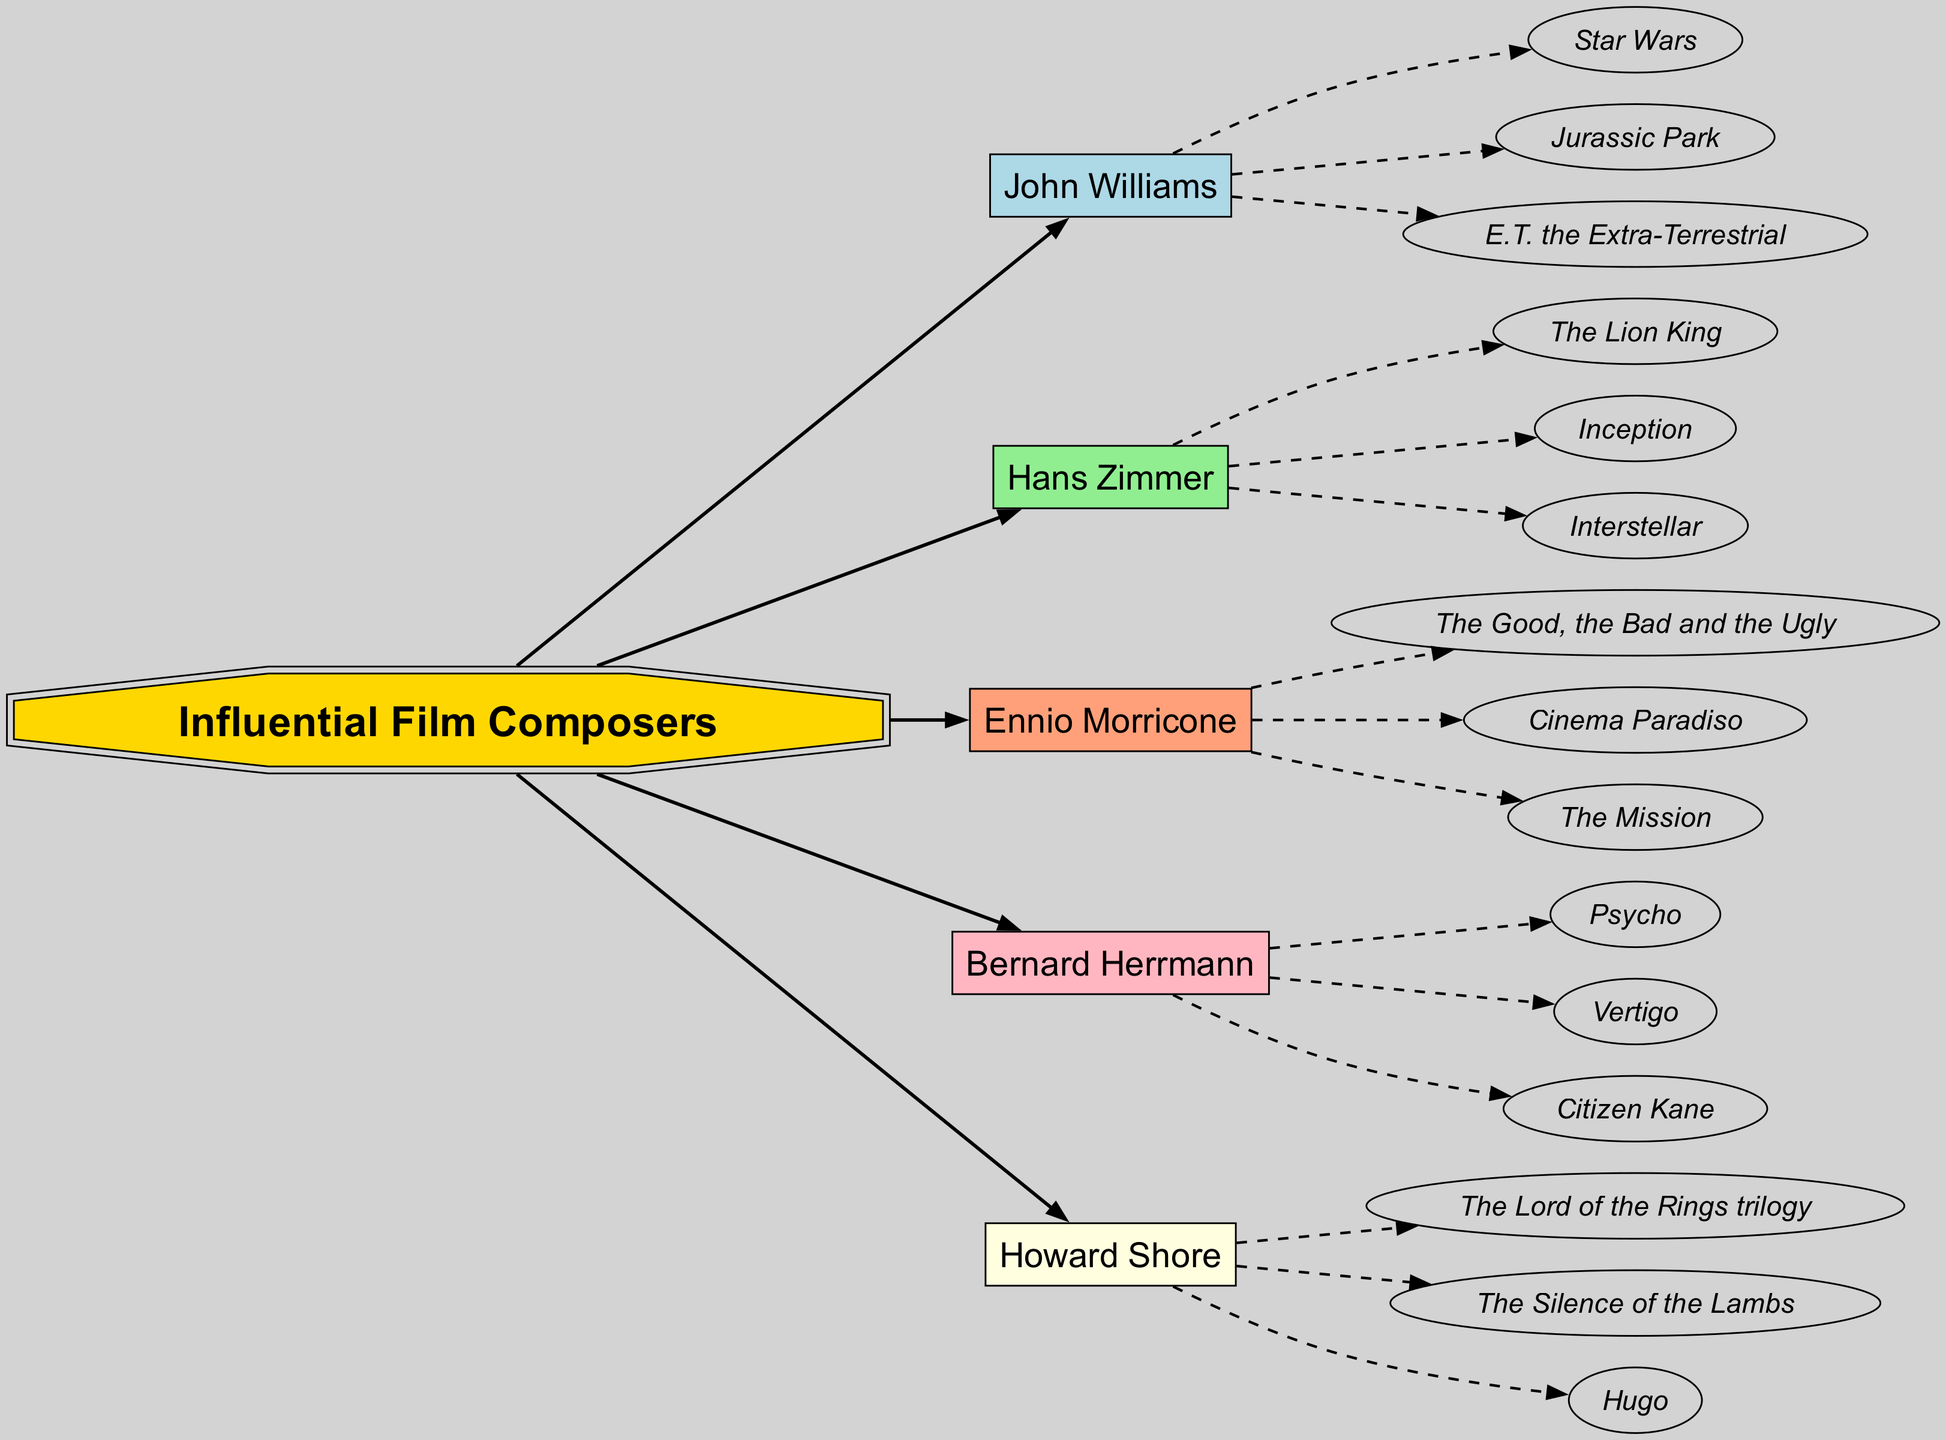What is the central theme of the diagram? The central theme, as indicated by the central node labeled "Influential Film Composers," is the impact and contribution of notable film composers in cinema history.
Answer: Influential Film Composers How many composers are featured in the diagram? The diagram lists five composers, each connected to the central theme node. I counted the nodes branching out from the center.
Answer: 5 Which composer is associated with the work "The Lion King"? The work "The Lion King" is linked to Hans Zimmer, as shown in the diagram. I traced the edge from the composer node to the work node.
Answer: Hans Zimmer What type of shapes represent the composers in the diagram? The composers are represented by box shapes, which are distinct from the oval shapes of the works, indicating a structural differentiation in the diagram.
Answer: Box Which composer has the most represented works in the diagram? Each composer in the diagram has three works listed, so the answer involves assessing the structure — all composers feature the same number of works.
Answer: Tie Who composed the score for "Psycho"? The score for "Psycho" was composed by Bernard Herrmann, as shown by the connection between his node and the work node in the diagram.
Answer: Bernard Herrmann What is a common theme among the works of Howard Shore? The common theme involves epic storytelling, particularly evidenced by his notable works like "The Lord of the Rings trilogy". I analyzed the titles connected by the dashed lines showing works related to his name.
Answer: Epic storytelling Which composer collaborated on "The Good, the Bad and the Ugly"? The composer associated with "The Good, the Bad and the Ugly" is Ennio Morricone, evident from the branch pointing to that specific work.
Answer: Ennio Morricone List one work associated with John Williams. One of the notable works associated with John Williams is "Star Wars," which is explicitly mentioned under his node.
Answer: Star Wars 